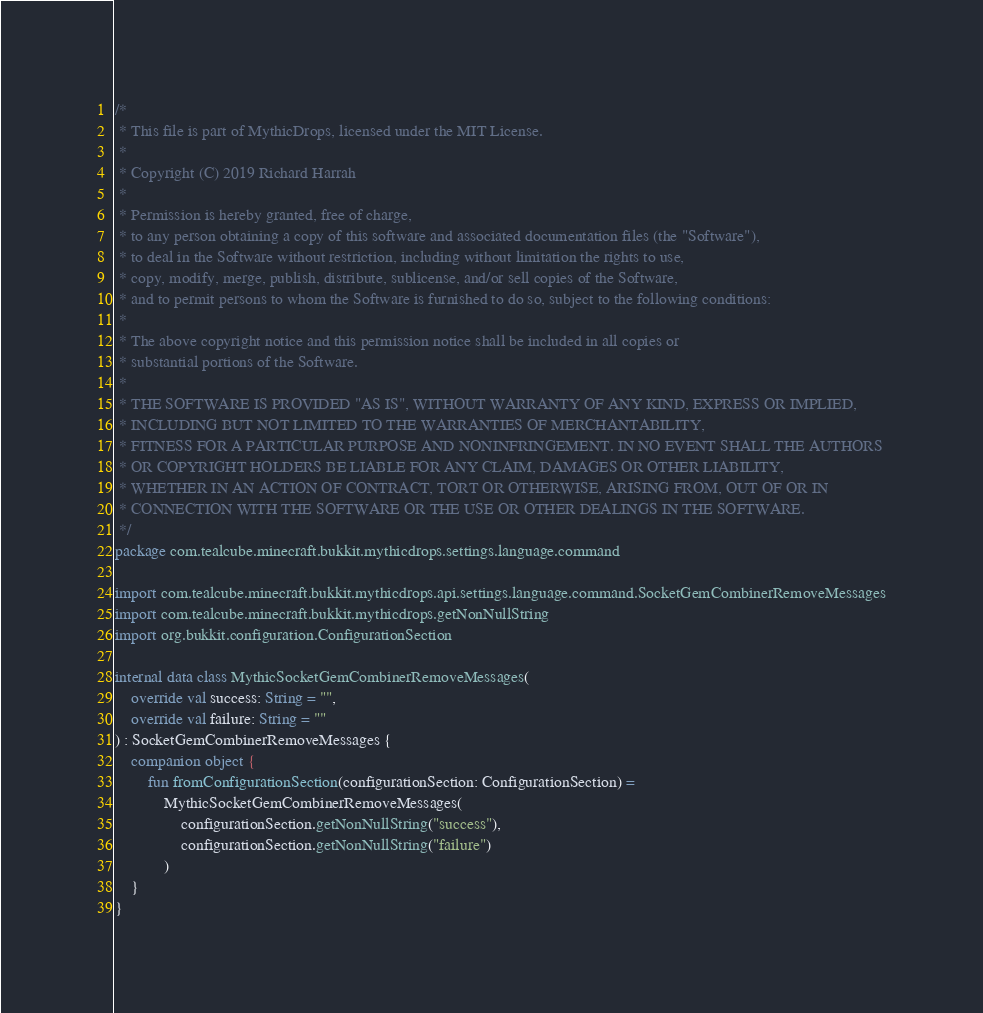<code> <loc_0><loc_0><loc_500><loc_500><_Kotlin_>/*
 * This file is part of MythicDrops, licensed under the MIT License.
 *
 * Copyright (C) 2019 Richard Harrah
 *
 * Permission is hereby granted, free of charge,
 * to any person obtaining a copy of this software and associated documentation files (the "Software"),
 * to deal in the Software without restriction, including without limitation the rights to use,
 * copy, modify, merge, publish, distribute, sublicense, and/or sell copies of the Software,
 * and to permit persons to whom the Software is furnished to do so, subject to the following conditions:
 *
 * The above copyright notice and this permission notice shall be included in all copies or
 * substantial portions of the Software.
 *
 * THE SOFTWARE IS PROVIDED "AS IS", WITHOUT WARRANTY OF ANY KIND, EXPRESS OR IMPLIED,
 * INCLUDING BUT NOT LIMITED TO THE WARRANTIES OF MERCHANTABILITY,
 * FITNESS FOR A PARTICULAR PURPOSE AND NONINFRINGEMENT. IN NO EVENT SHALL THE AUTHORS
 * OR COPYRIGHT HOLDERS BE LIABLE FOR ANY CLAIM, DAMAGES OR OTHER LIABILITY,
 * WHETHER IN AN ACTION OF CONTRACT, TORT OR OTHERWISE, ARISING FROM, OUT OF OR IN
 * CONNECTION WITH THE SOFTWARE OR THE USE OR OTHER DEALINGS IN THE SOFTWARE.
 */
package com.tealcube.minecraft.bukkit.mythicdrops.settings.language.command

import com.tealcube.minecraft.bukkit.mythicdrops.api.settings.language.command.SocketGemCombinerRemoveMessages
import com.tealcube.minecraft.bukkit.mythicdrops.getNonNullString
import org.bukkit.configuration.ConfigurationSection

internal data class MythicSocketGemCombinerRemoveMessages(
    override val success: String = "",
    override val failure: String = ""
) : SocketGemCombinerRemoveMessages {
    companion object {
        fun fromConfigurationSection(configurationSection: ConfigurationSection) =
            MythicSocketGemCombinerRemoveMessages(
                configurationSection.getNonNullString("success"),
                configurationSection.getNonNullString("failure")
            )
    }
}
</code> 